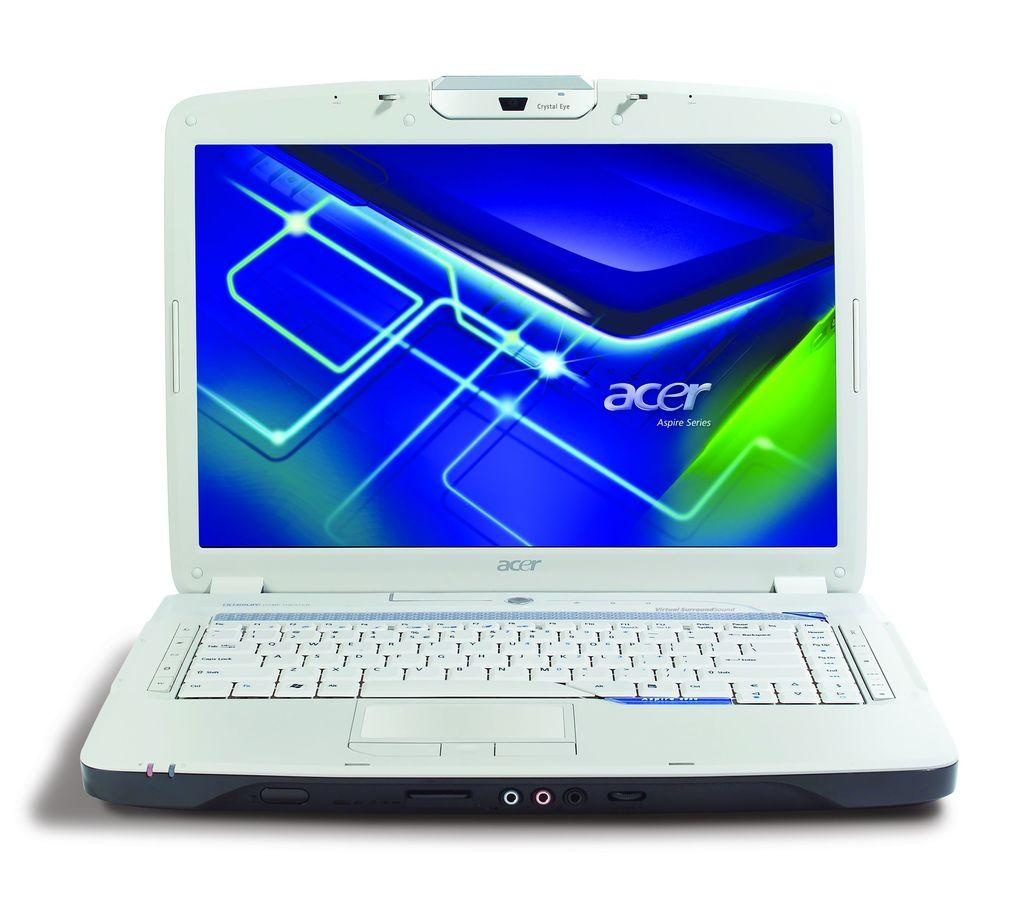<image>
Provide a brief description of the given image. The white laptop pictured is made by Acer. 